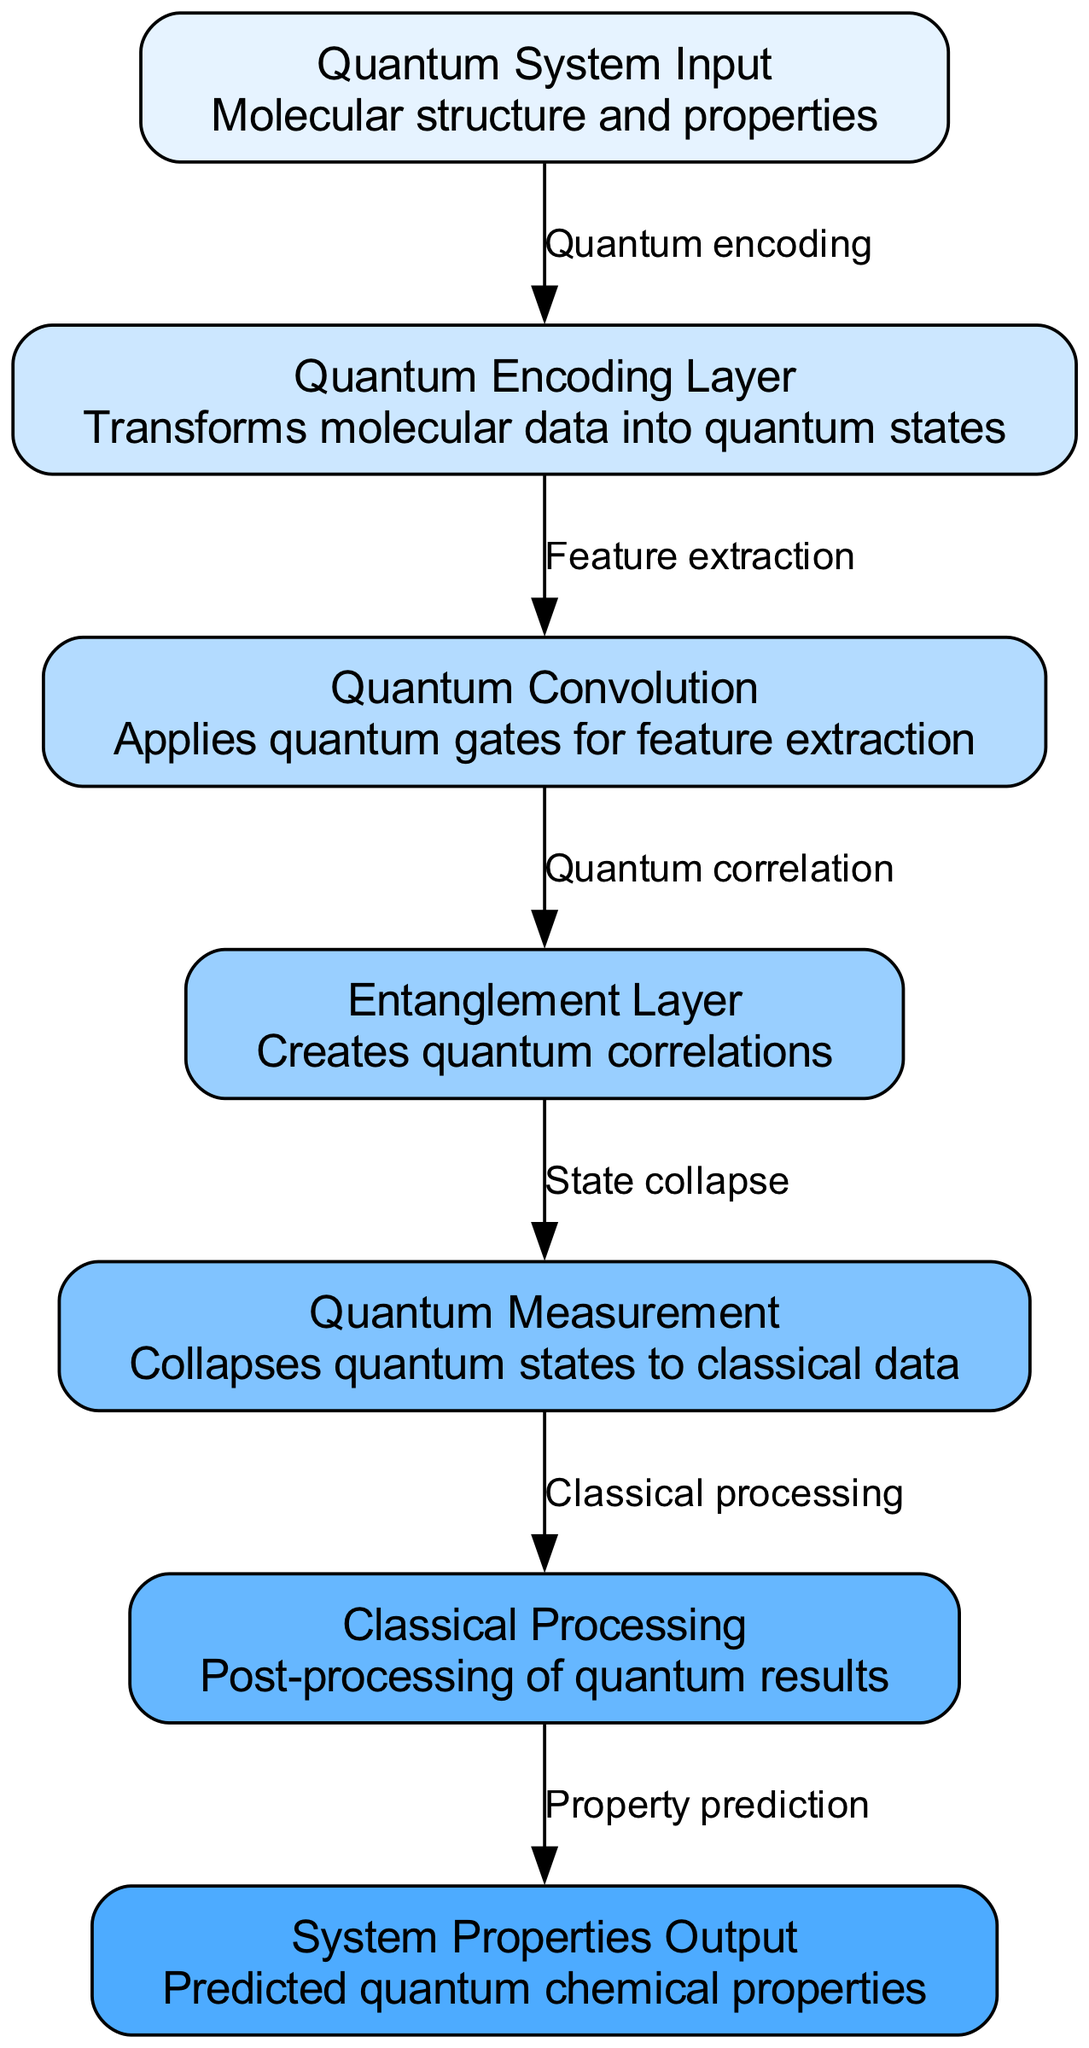What is the input of the neural network? The diagram labels the input node clearly, stating that it is "Quantum System Input," which consists of "Molecular structure and properties."
Answer: Quantum System Input How many nodes are in the diagram? A count of the nodes in the diagram reveals there are seven distinct nodes, including input, encoding, qconv, entanglement, measurement, classical, and output.
Answer: Seven What process occurs after the Quantum Convolution? Looking at the edges, the process that follows "Quantum Convolution" is the "Entanglement Layer," indicating that quantum correlations are created next.
Answer: Entanglement Layer Which layer transforms molecular data? Referring to the diagram, the "Quantum Encoding Layer" is responsible for transforming molecular data into quantum states right after the input is provided.
Answer: Quantum Encoding Layer What is the output of the neural network? The final node labeled in the diagram is "System Properties Output," indicating that predictions of quantum chemical properties are the end results of the network.
Answer: System Properties Output What is the relationship between the Measurement and Classical Processing nodes? According to the edge connecting these two nodes, "Measurement" relates to "Classical Processing" by performing the "Classical processing" of the quantum results from the previous measurement.
Answer: Classical processing Name the layer that applies quantum gates. The edge leading from "Quantum Encoding Layer" to "Quantum Convolution" shows that feature extraction occurs with the application of "Quantum gates" in this layer.
Answer: Quantum Convolution How many connections are in the diagram? By counting the edges connecting the nodes, there are six distinct connections, indicating the flow of information through the architecture.
Answer: Six 